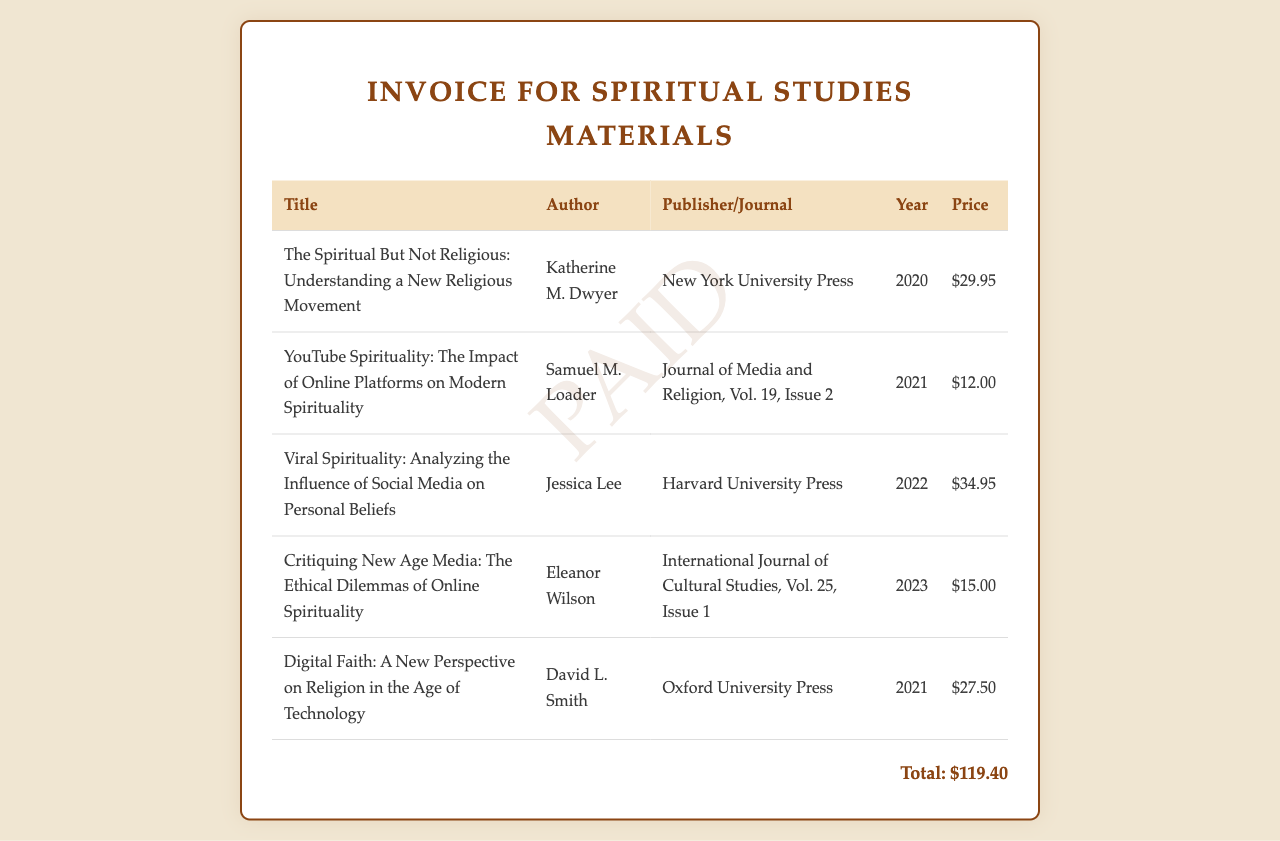what is the title of the first book? The title of the first book listed in the invoice is found in the first row of the book list.
Answer: The Spiritual But Not Religious: Understanding a New Religious Movement who is the author of "Viral Spirituality"? The name of the author is found in the row corresponding to "Viral Spirituality".
Answer: Jessica Lee what is the total amount of the invoice? The total amount is provided at the bottom of the invoice, summing up all book prices.
Answer: $119.40 which publisher released "Digital Faith"? The publisher can be identified from the entry for "Digital Faith" in the invoice.
Answer: Oxford University Press what year was "YouTube Spirituality" published? The publication year is listed in the corresponding column for "YouTube Spirituality".
Answer: 2021 which journal featured the article "Critiquing New Age Media"? This information is located in the publisher/journal column for the corresponding entry.
Answer: International Journal of Cultural Studies how many books are listed in the invoice? The number of books can be counted from the rows present in the table.
Answer: 5 which book has the highest price? The highest price can be determined by comparing the price column in the table.
Answer: Viral Spirituality: Analyzing the Influence of Social Media on Personal Beliefs what is the color of the invoice's header? The header color is described in the styling portion of the document that dictates its visual representation.
Answer: #8b4513 